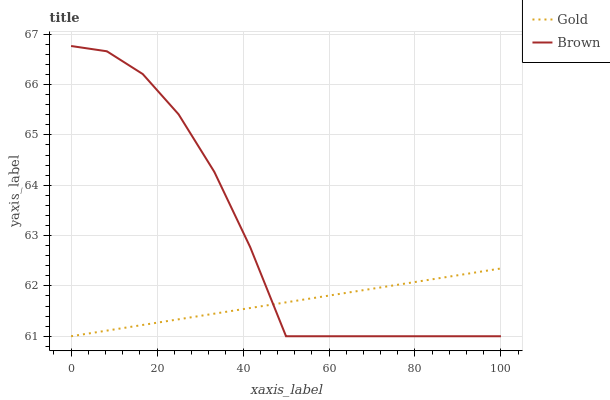Does Gold have the maximum area under the curve?
Answer yes or no. No. Is Gold the roughest?
Answer yes or no. No. Does Gold have the highest value?
Answer yes or no. No. 